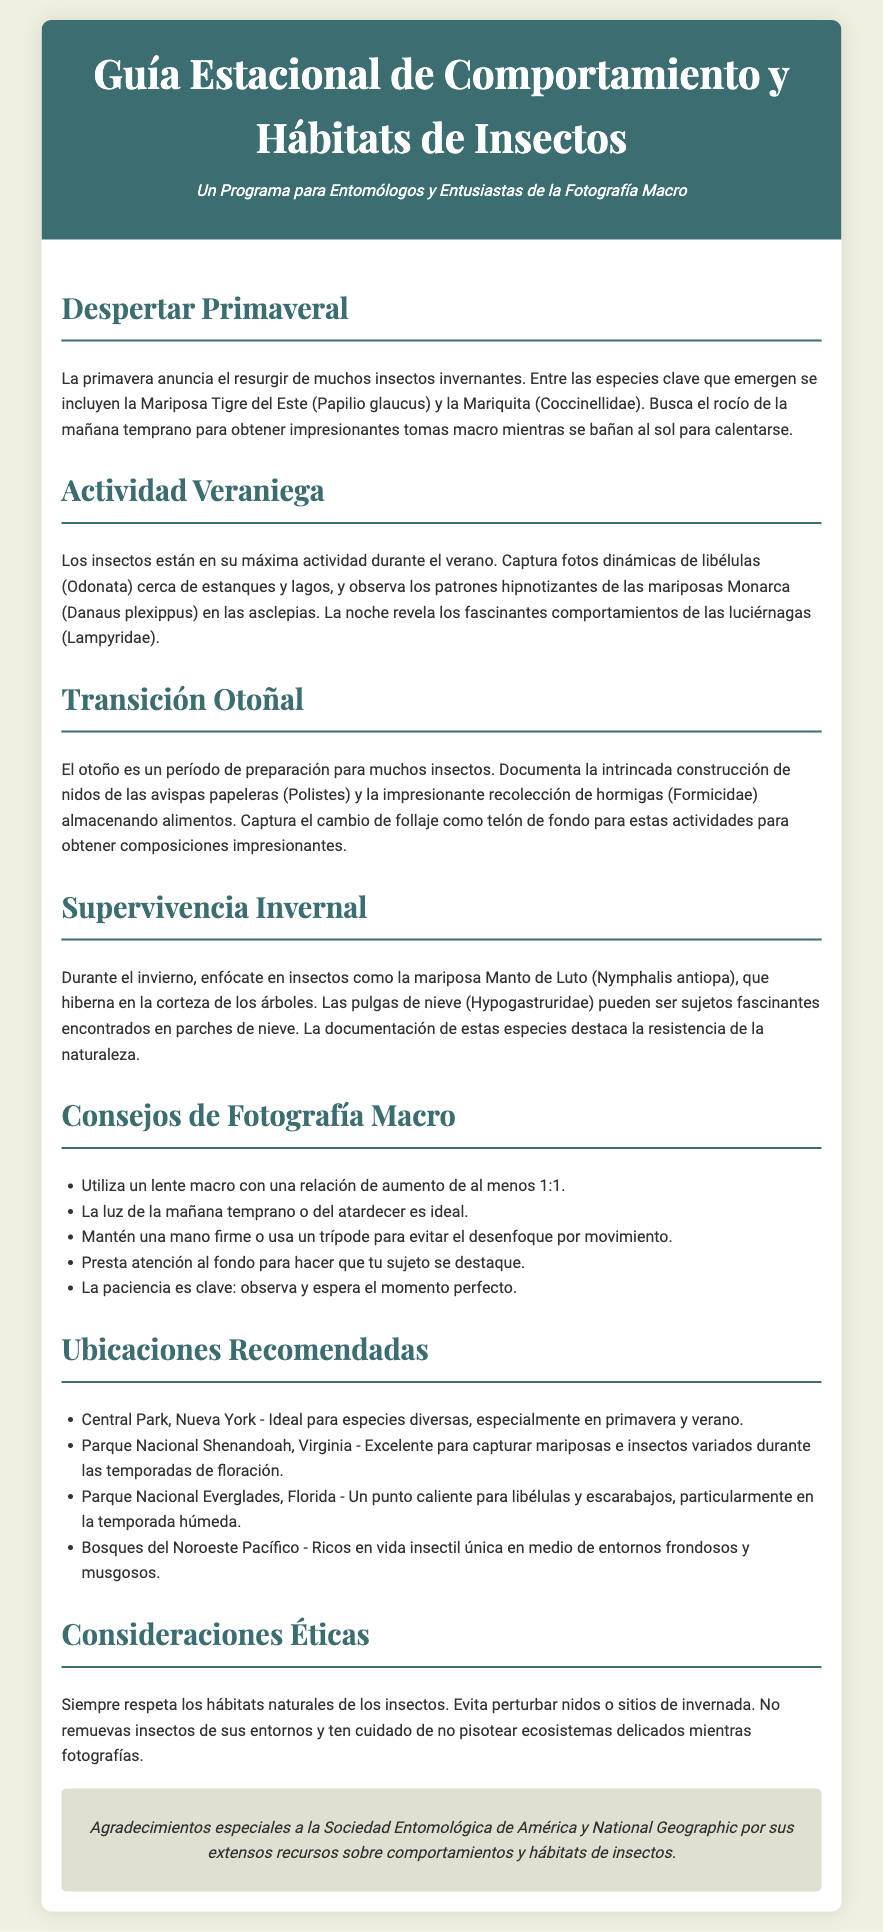¿Cuáles insectos emergen en primavera? La primavera anuncia el resurgir de insectos invernantes, incluyendo la Mariposa Tigre del Este y la Mariquita.
Answer: Mariposa Tigre del Este y Mariquita ¿Qué tipo de insectos están más activos en verano? Durante el verano, los insectos están en su máxima actividad, como libélulas y mariposas Monarca.
Answer: Libélulas y mariposas Monarca ¿Qué comportamiento de las avispas se puede documentar en otoño? En otoño, se puede documentar la intrincada construcción de nidos de las avispas papeleras.
Answer: Construcción de nidos ¿Qué mariposa hiberna en invierno? Durante el invierno, la mariposa Manto de Luto hiberna en la corteza de los árboles.
Answer: Mariposa Manto de Luto ¿Cuál es un tip para la fotografía macro? Un consejo de fotografía macro es utilizar un lente macro con una relación de aumento de al menos 1:1.
Answer: Lente macro 1:1 ¿Cuál es una ubicación recomendada para fotografiar insectos en primavera? Central Park, Nueva York es ideal para especies diversas, especialmente en primavera y verano.
Answer: Central Park, Nueva York ¿Qué consideración ética se debe tener al fotografiar insectos? Siempre respeta los hábitats naturales de los insectos evitando perturbar nidos o sitios de invernada.
Answer: Respetar hábitats naturales ¿Cuál es el enfoque al fotografiar a las luciérnagas? La noche revela los fascinantes comportamientos de las luciérnagas.
Answer: Comportamientos de luciérnagas 